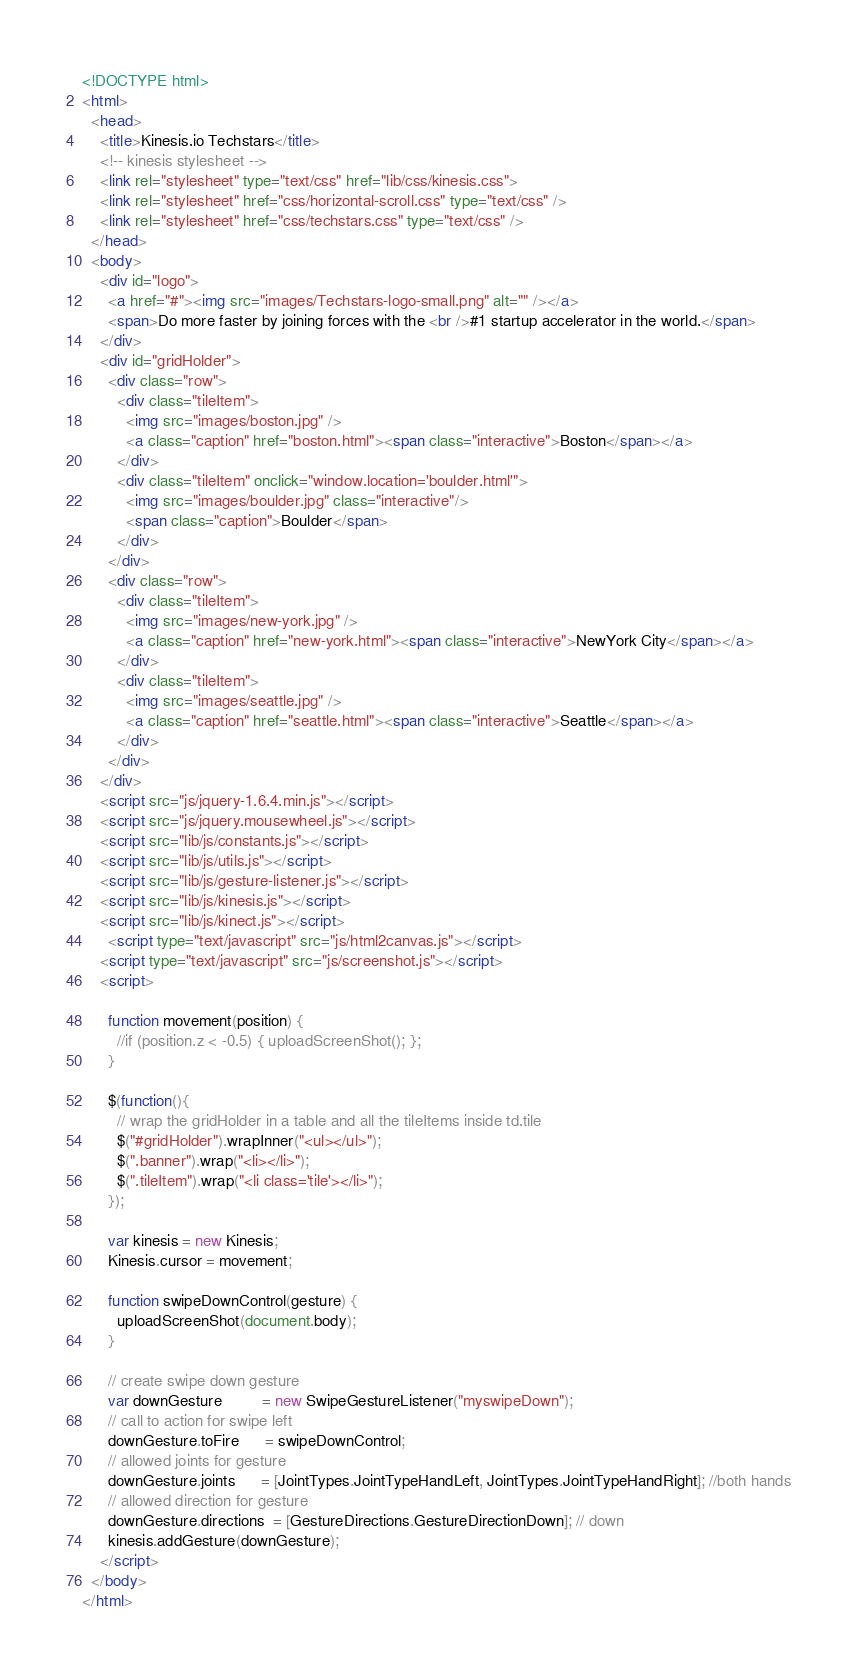<code> <loc_0><loc_0><loc_500><loc_500><_HTML_><!DOCTYPE html>
<html>
  <head>
    <title>Kinesis.io Techstars</title>
    <!-- kinesis stylesheet -->
    <link rel="stylesheet" type="text/css" href="lib/css/kinesis.css">
  	<link rel="stylesheet" href="css/horizontal-scroll.css" type="text/css" />
  	<link rel="stylesheet" href="css/techstars.css" type="text/css" />
  </head>
  <body>
    <div id="logo">
      <a href="#"><img src="images/Techstars-logo-small.png" alt="" /></a>
      <span>Do more faster by joining forces with the <br />#1 startup accelerator in the world.</span>
    </div>
    <div id="gridHolder">
      <div class="row">
        <div class="tileItem">
          <img src="images/boston.jpg" />
          <a class="caption" href="boston.html"><span class="interactive">Boston</span></a>
        </div>
        <div class="tileItem" onclick="window.location='boulder.html'">
          <img src="images/boulder.jpg" class="interactive"/>
          <span class="caption">Boulder</span>
        </div>
      </div>  
      <div class="row">
        <div class="tileItem">
          <img src="images/new-york.jpg" />
          <a class="caption" href="new-york.html"><span class="interactive">NewYork City</span></a>
        </div>
        <div class="tileItem">
          <img src="images/seattle.jpg" />
          <a class="caption" href="seattle.html"><span class="interactive">Seattle</span></a>
        </div>
      </div>  
    </div>
    <script src="js/jquery-1.6.4.min.js"></script>
  	<script src="js/jquery.mousewheel.js"></script>
  	<script src="lib/js/constants.js"></script>
    <script src="lib/js/utils.js"></script>
    <script src="lib/js/gesture-listener.js"></script>
    <script src="lib/js/kinesis.js"></script>
    <script src="lib/js/kinect.js"></script>
	  <script type="text/javascript" src="js/html2canvas.js"></script>
    <script type="text/javascript" src="js/screenshot.js"></script>
  	<script>

      function movement(position) {
        //if (position.z < -0.5) { uploadScreenShot(); };
      }

  	  $(function(){
        // wrap the gridHolder in a table and all the tileItems inside td.tile
        $("#gridHolder").wrapInner("<ul></ul>");
      	$(".banner").wrap("<li></li>");
      	$(".tileItem").wrap("<li class='tile'></li>");
      });

      var kinesis = new Kinesis;
      Kinesis.cursor = movement;

      function swipeDownControl(gesture) {
        uploadScreenShot(document.body);
      }

      // create swipe down gesture
      var downGesture         = new SwipeGestureListener("myswipeDown");
      // call to action for swipe left
      downGesture.toFire      = swipeDownControl;
      // allowed joints for gesture
      downGesture.joints      = [JointTypes.JointTypeHandLeft, JointTypes.JointTypeHandRight]; //both hands
      // allowed direction for gesture
      downGesture.directions  = [GestureDirections.GestureDirectionDown]; // down
      kinesis.addGesture(downGesture);
    </script>
  </body>
</html>
</code> 